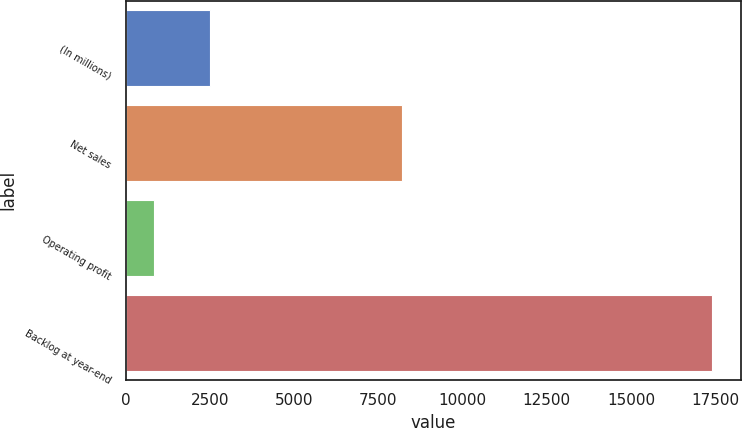Convert chart to OTSL. <chart><loc_0><loc_0><loc_500><loc_500><bar_chart><fcel>(In millions)<fcel>Net sales<fcel>Operating profit<fcel>Backlog at year-end<nl><fcel>2510.4<fcel>8203<fcel>856<fcel>17400<nl></chart> 